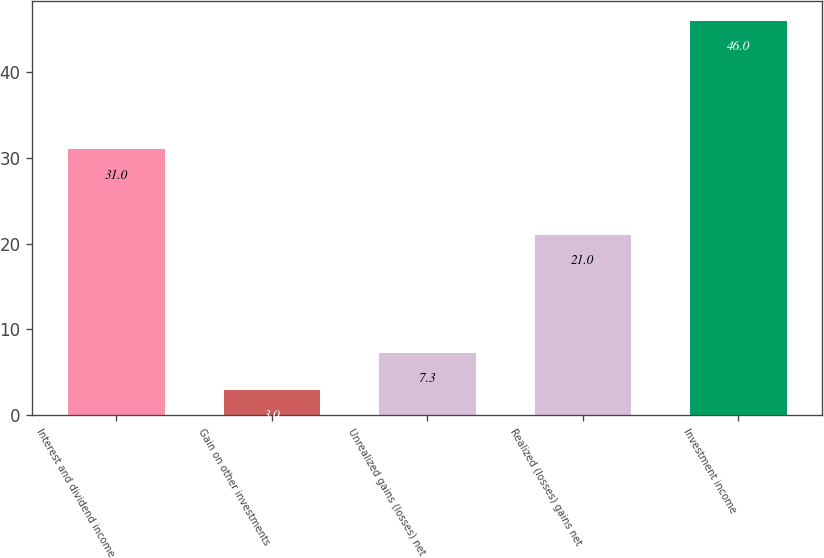<chart> <loc_0><loc_0><loc_500><loc_500><bar_chart><fcel>Interest and dividend income<fcel>Gain on other investments<fcel>Unrealized gains (losses) net<fcel>Realized (losses) gains net<fcel>Investment income<nl><fcel>31<fcel>3<fcel>7.3<fcel>21<fcel>46<nl></chart> 